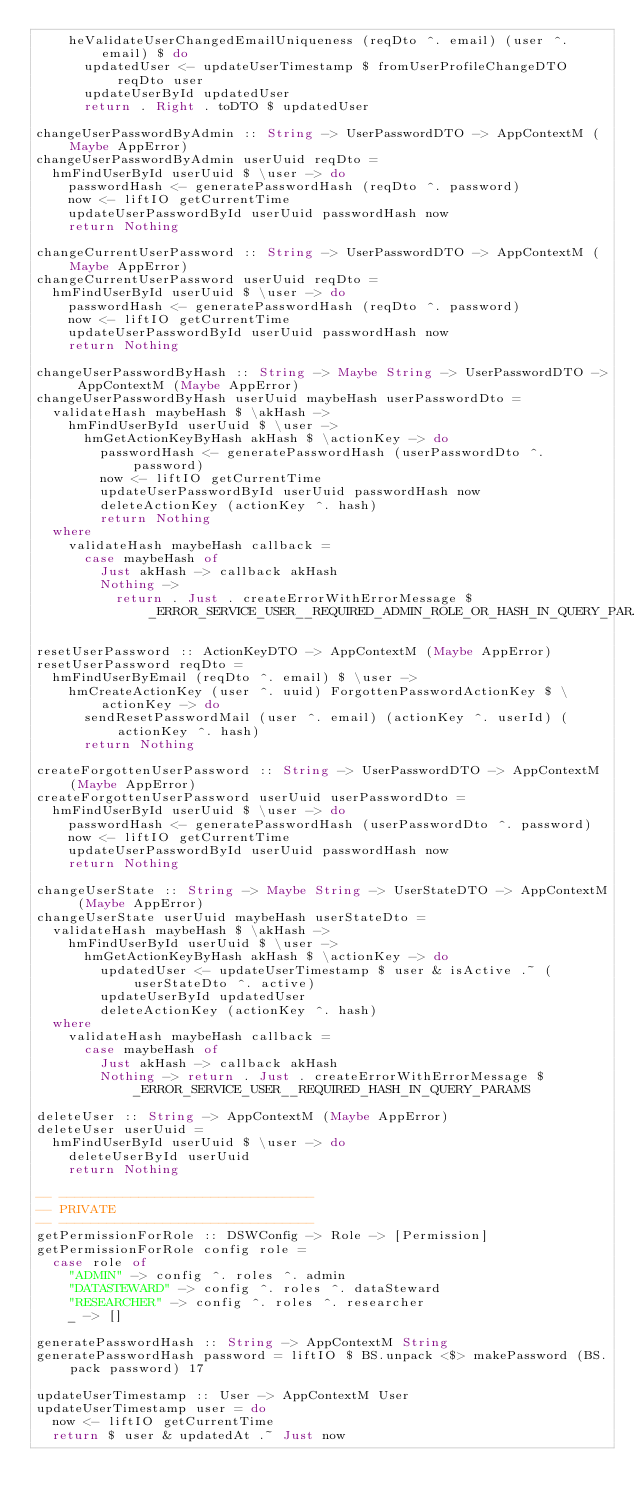<code> <loc_0><loc_0><loc_500><loc_500><_Haskell_>    heValidateUserChangedEmailUniqueness (reqDto ^. email) (user ^. email) $ do
      updatedUser <- updateUserTimestamp $ fromUserProfileChangeDTO reqDto user
      updateUserById updatedUser
      return . Right . toDTO $ updatedUser

changeUserPasswordByAdmin :: String -> UserPasswordDTO -> AppContextM (Maybe AppError)
changeUserPasswordByAdmin userUuid reqDto =
  hmFindUserById userUuid $ \user -> do
    passwordHash <- generatePasswordHash (reqDto ^. password)
    now <- liftIO getCurrentTime
    updateUserPasswordById userUuid passwordHash now
    return Nothing

changeCurrentUserPassword :: String -> UserPasswordDTO -> AppContextM (Maybe AppError)
changeCurrentUserPassword userUuid reqDto =
  hmFindUserById userUuid $ \user -> do
    passwordHash <- generatePasswordHash (reqDto ^. password)
    now <- liftIO getCurrentTime
    updateUserPasswordById userUuid passwordHash now
    return Nothing

changeUserPasswordByHash :: String -> Maybe String -> UserPasswordDTO -> AppContextM (Maybe AppError)
changeUserPasswordByHash userUuid maybeHash userPasswordDto =
  validateHash maybeHash $ \akHash ->
    hmFindUserById userUuid $ \user ->
      hmGetActionKeyByHash akHash $ \actionKey -> do
        passwordHash <- generatePasswordHash (userPasswordDto ^. password)
        now <- liftIO getCurrentTime
        updateUserPasswordById userUuid passwordHash now
        deleteActionKey (actionKey ^. hash)
        return Nothing
  where
    validateHash maybeHash callback =
      case maybeHash of
        Just akHash -> callback akHash
        Nothing ->
          return . Just . createErrorWithErrorMessage $ _ERROR_SERVICE_USER__REQUIRED_ADMIN_ROLE_OR_HASH_IN_QUERY_PARAMS

resetUserPassword :: ActionKeyDTO -> AppContextM (Maybe AppError)
resetUserPassword reqDto =
  hmFindUserByEmail (reqDto ^. email) $ \user ->
    hmCreateActionKey (user ^. uuid) ForgottenPasswordActionKey $ \actionKey -> do
      sendResetPasswordMail (user ^. email) (actionKey ^. userId) (actionKey ^. hash)
      return Nothing

createForgottenUserPassword :: String -> UserPasswordDTO -> AppContextM (Maybe AppError)
createForgottenUserPassword userUuid userPasswordDto =
  hmFindUserById userUuid $ \user -> do
    passwordHash <- generatePasswordHash (userPasswordDto ^. password)
    now <- liftIO getCurrentTime
    updateUserPasswordById userUuid passwordHash now
    return Nothing

changeUserState :: String -> Maybe String -> UserStateDTO -> AppContextM (Maybe AppError)
changeUserState userUuid maybeHash userStateDto =
  validateHash maybeHash $ \akHash ->
    hmFindUserById userUuid $ \user ->
      hmGetActionKeyByHash akHash $ \actionKey -> do
        updatedUser <- updateUserTimestamp $ user & isActive .~ (userStateDto ^. active)
        updateUserById updatedUser
        deleteActionKey (actionKey ^. hash)
  where
    validateHash maybeHash callback =
      case maybeHash of
        Just akHash -> callback akHash
        Nothing -> return . Just . createErrorWithErrorMessage $ _ERROR_SERVICE_USER__REQUIRED_HASH_IN_QUERY_PARAMS

deleteUser :: String -> AppContextM (Maybe AppError)
deleteUser userUuid =
  hmFindUserById userUuid $ \user -> do
    deleteUserById userUuid
    return Nothing

-- --------------------------------
-- PRIVATE
-- --------------------------------
getPermissionForRole :: DSWConfig -> Role -> [Permission]
getPermissionForRole config role =
  case role of
    "ADMIN" -> config ^. roles ^. admin
    "DATASTEWARD" -> config ^. roles ^. dataSteward
    "RESEARCHER" -> config ^. roles ^. researcher
    _ -> []

generatePasswordHash :: String -> AppContextM String
generatePasswordHash password = liftIO $ BS.unpack <$> makePassword (BS.pack password) 17

updateUserTimestamp :: User -> AppContextM User
updateUserTimestamp user = do
  now <- liftIO getCurrentTime
  return $ user & updatedAt .~ Just now
</code> 